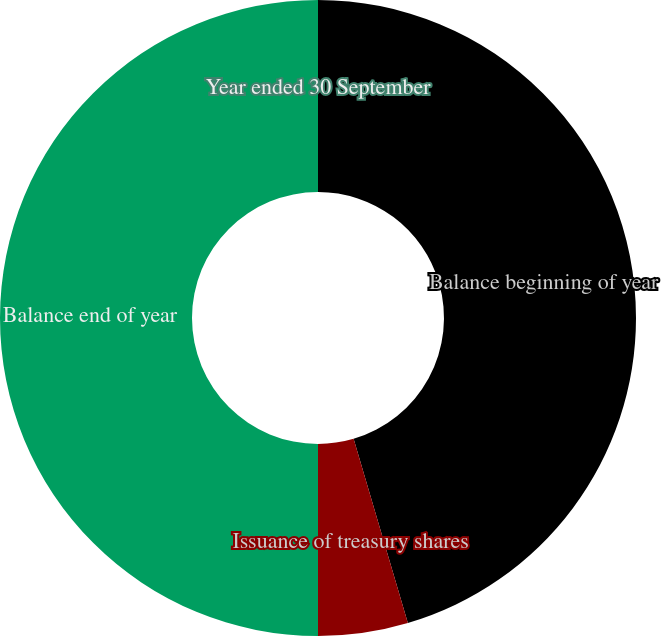<chart> <loc_0><loc_0><loc_500><loc_500><pie_chart><fcel>Year ended 30 September<fcel>Balance beginning of year<fcel>Issuance of treasury shares<fcel>Balance end of year<nl><fcel>0.0%<fcel>45.44%<fcel>4.56%<fcel>50.0%<nl></chart> 